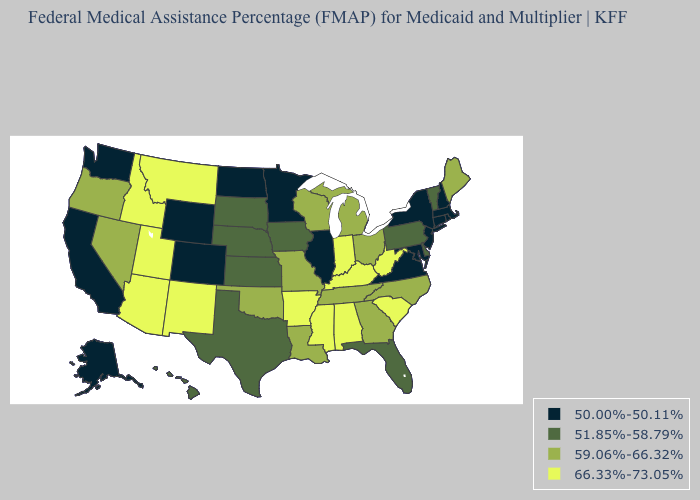Name the states that have a value in the range 59.06%-66.32%?
Quick response, please. Georgia, Louisiana, Maine, Michigan, Missouri, Nevada, North Carolina, Ohio, Oklahoma, Oregon, Tennessee, Wisconsin. What is the highest value in states that border Wyoming?
Be succinct. 66.33%-73.05%. What is the value of Virginia?
Answer briefly. 50.00%-50.11%. What is the highest value in the West ?
Concise answer only. 66.33%-73.05%. Which states have the lowest value in the USA?
Be succinct. Alaska, California, Colorado, Connecticut, Illinois, Maryland, Massachusetts, Minnesota, New Hampshire, New Jersey, New York, North Dakota, Rhode Island, Virginia, Washington, Wyoming. What is the highest value in states that border Michigan?
Answer briefly. 66.33%-73.05%. Which states have the highest value in the USA?
Short answer required. Alabama, Arizona, Arkansas, Idaho, Indiana, Kentucky, Mississippi, Montana, New Mexico, South Carolina, Utah, West Virginia. What is the value of Vermont?
Keep it brief. 51.85%-58.79%. Name the states that have a value in the range 66.33%-73.05%?
Quick response, please. Alabama, Arizona, Arkansas, Idaho, Indiana, Kentucky, Mississippi, Montana, New Mexico, South Carolina, Utah, West Virginia. Name the states that have a value in the range 51.85%-58.79%?
Keep it brief. Delaware, Florida, Hawaii, Iowa, Kansas, Nebraska, Pennsylvania, South Dakota, Texas, Vermont. Among the states that border California , which have the highest value?
Give a very brief answer. Arizona. Does the first symbol in the legend represent the smallest category?
Answer briefly. Yes. What is the value of Oklahoma?
Short answer required. 59.06%-66.32%. What is the value of New Hampshire?
Short answer required. 50.00%-50.11%. 